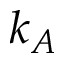Convert formula to latex. <formula><loc_0><loc_0><loc_500><loc_500>k _ { A }</formula> 